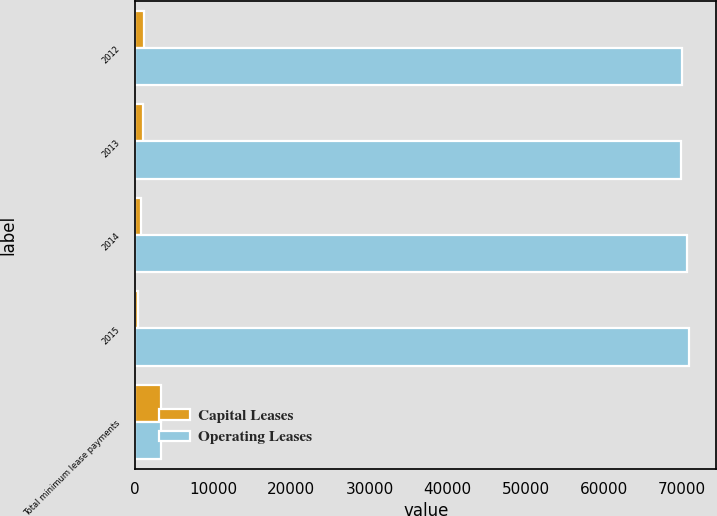Convert chart to OTSL. <chart><loc_0><loc_0><loc_500><loc_500><stacked_bar_chart><ecel><fcel>2012<fcel>2013<fcel>2014<fcel>2015<fcel>Total minimum lease payments<nl><fcel>Capital Leases<fcel>1124<fcel>989<fcel>808<fcel>440<fcel>3361<nl><fcel>Operating Leases<fcel>70052<fcel>69917<fcel>70588<fcel>70866<fcel>3361<nl></chart> 